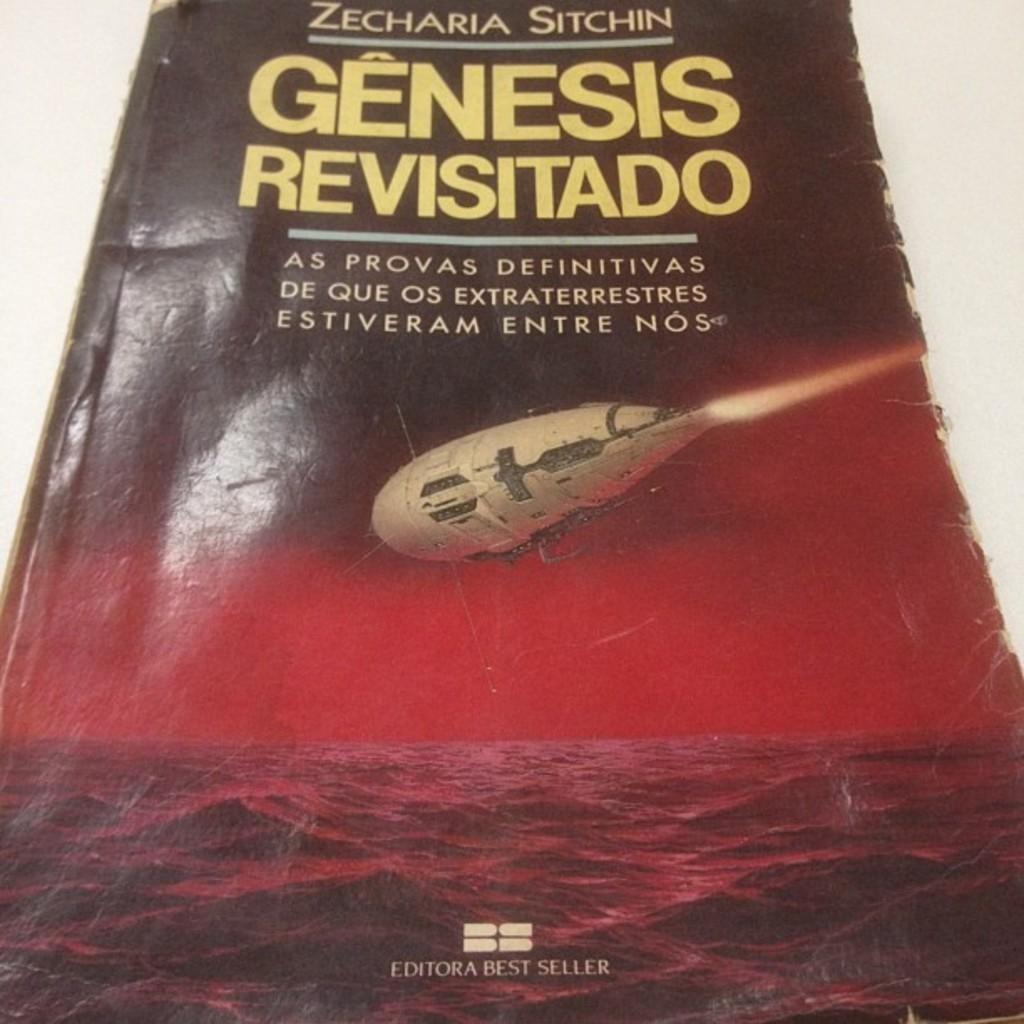<image>
Create a compact narrative representing the image presented. A cover of the book titled Genesis Revisitado by Zecharia Sitchin. 